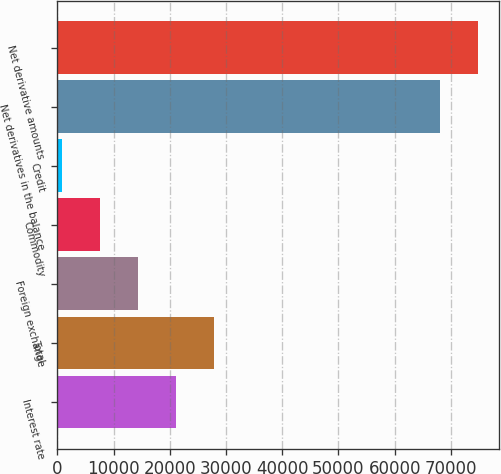<chart> <loc_0><loc_0><loc_500><loc_500><bar_chart><fcel>Interest rate<fcel>Total<fcel>Foreign exchange<fcel>Commodity<fcel>Credit<fcel>Net derivatives in the balance<fcel>Net derivative amounts<nl><fcel>21060.1<fcel>27776.8<fcel>14343.4<fcel>7626.7<fcel>910<fcel>68077<fcel>74793.7<nl></chart> 